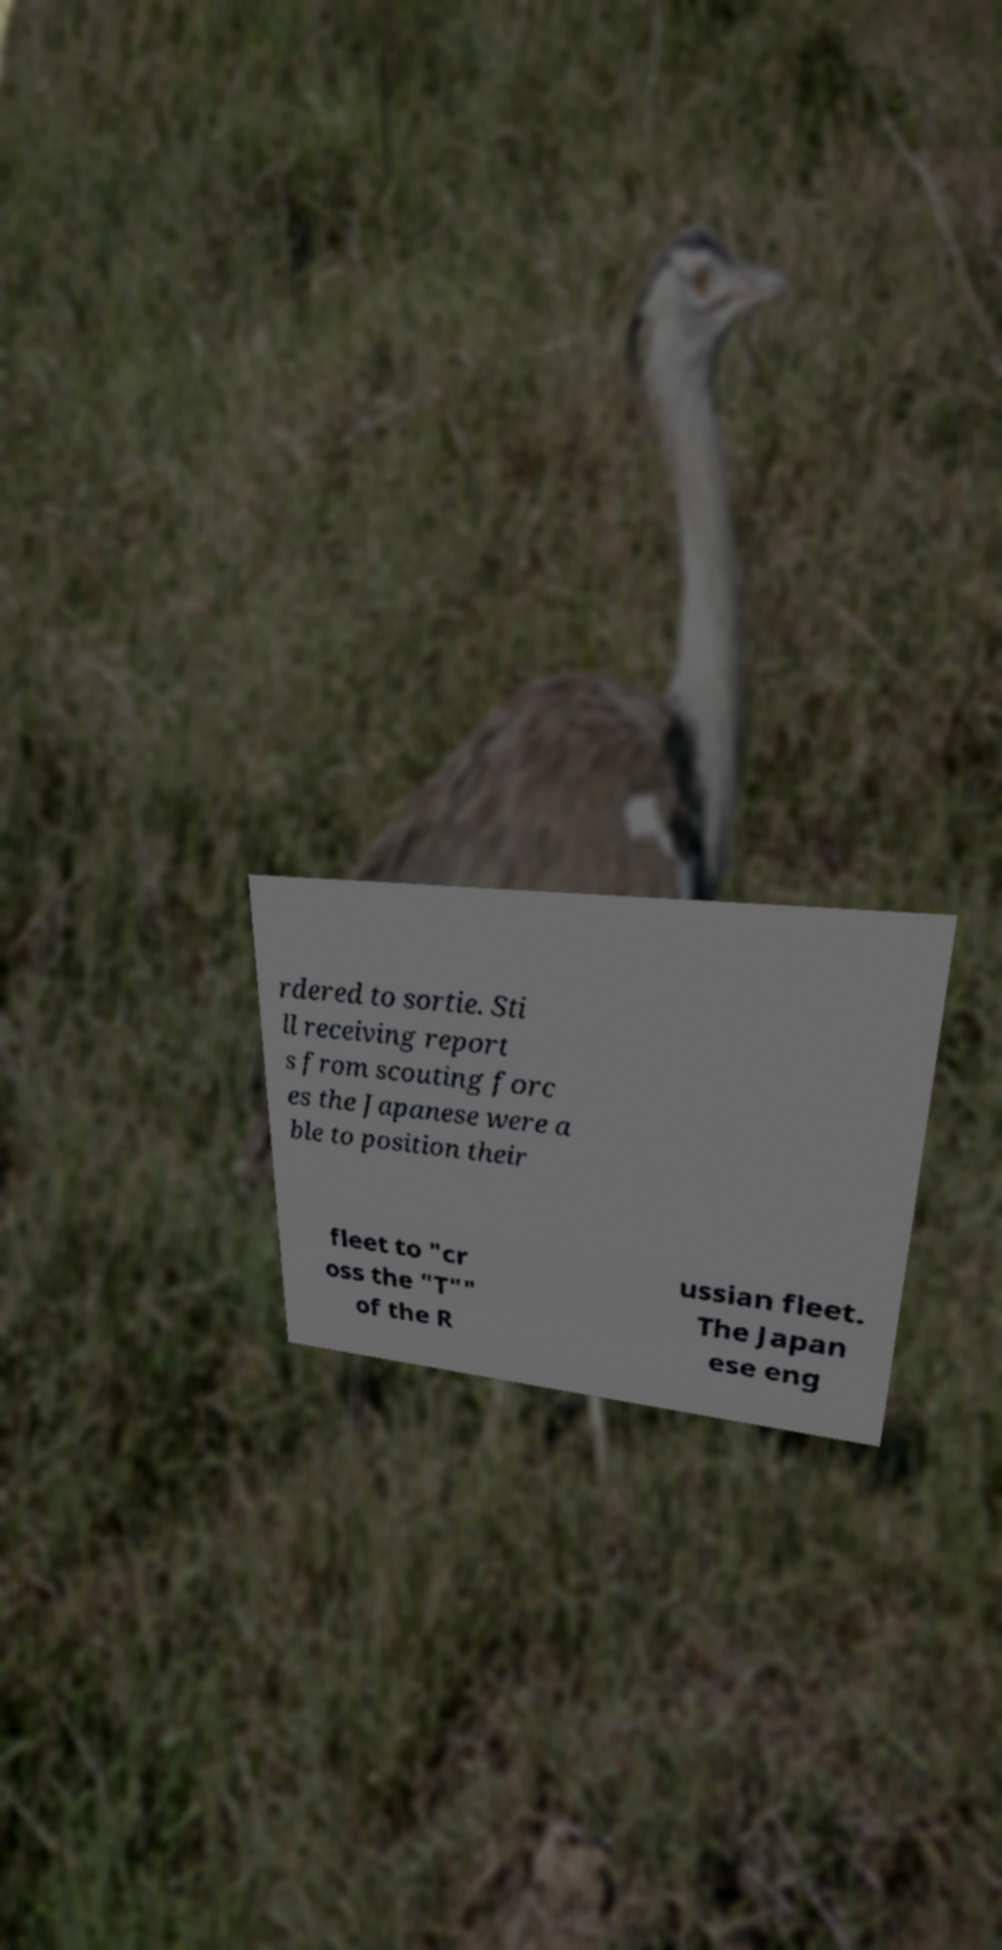Please identify and transcribe the text found in this image. rdered to sortie. Sti ll receiving report s from scouting forc es the Japanese were a ble to position their fleet to "cr oss the "T"" of the R ussian fleet. The Japan ese eng 